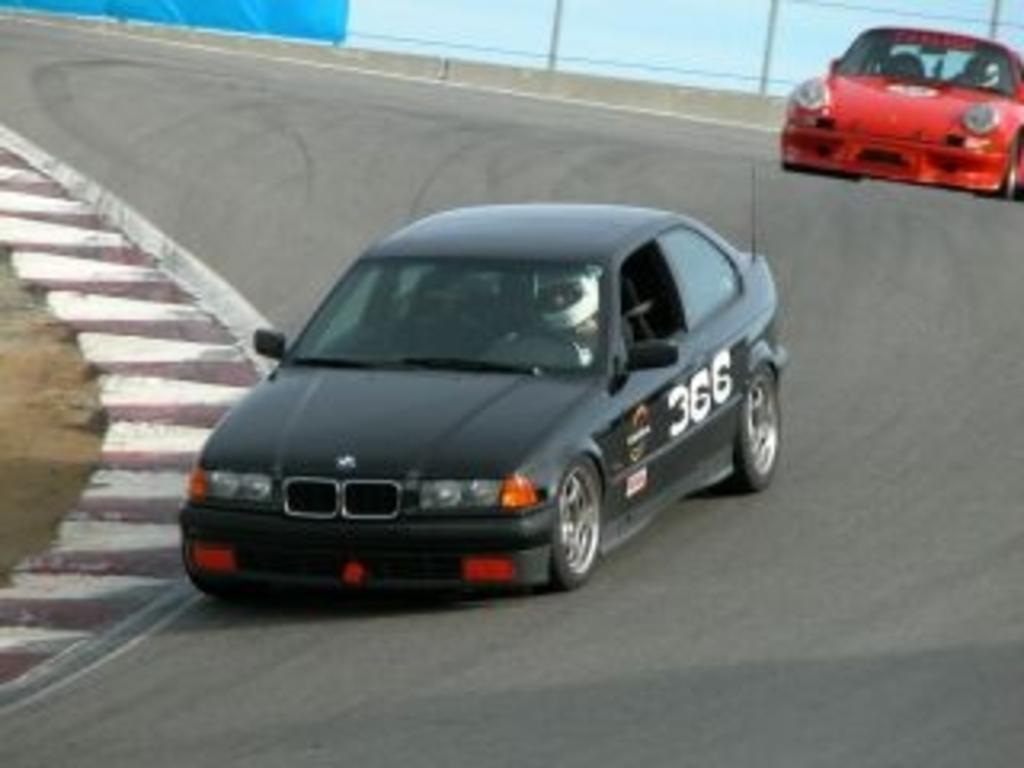How would you summarize this image in a sentence or two? In this image we can see two cars on the road. On the backside we can see a fence. 